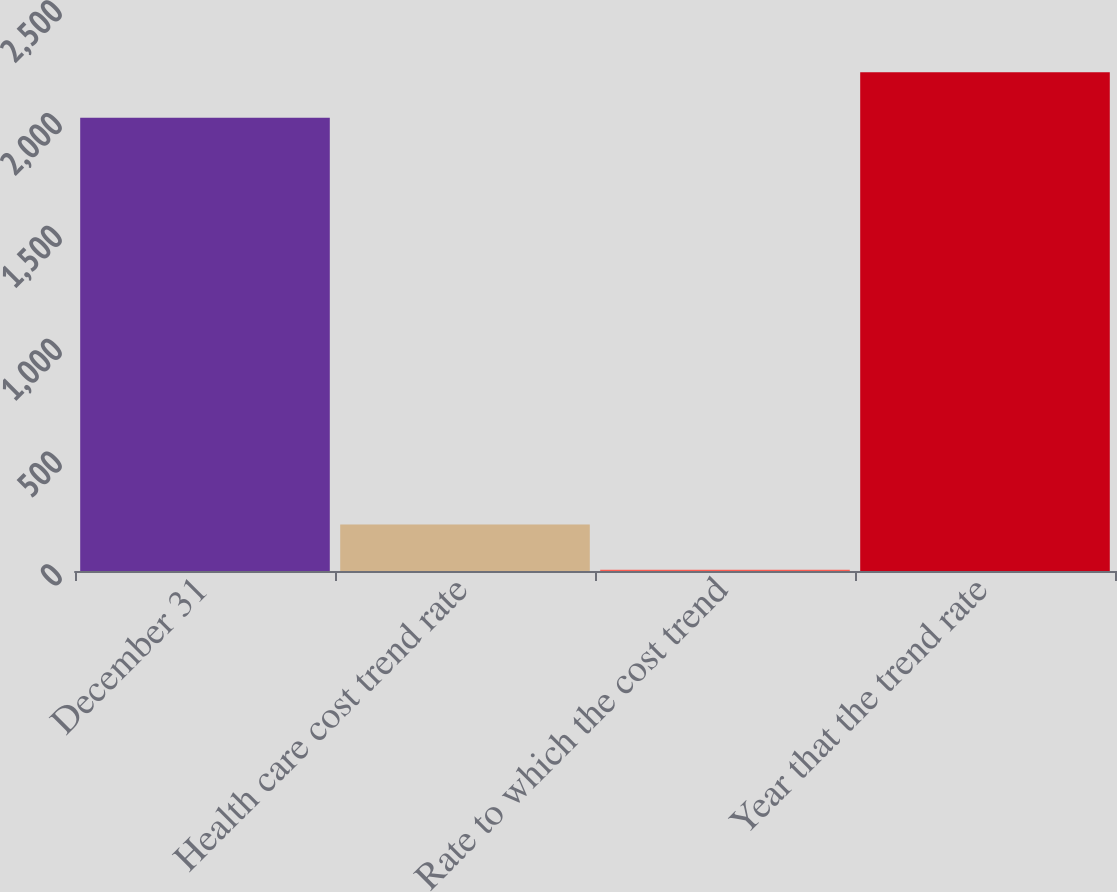Convert chart to OTSL. <chart><loc_0><loc_0><loc_500><loc_500><bar_chart><fcel>December 31<fcel>Health care cost trend rate<fcel>Rate to which the cost trend<fcel>Year that the trend rate<nl><fcel>2009<fcel>206.3<fcel>5<fcel>2210.3<nl></chart> 